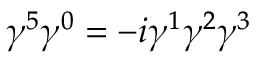<formula> <loc_0><loc_0><loc_500><loc_500>\gamma ^ { 5 } \gamma ^ { 0 } = - i \gamma ^ { 1 } \gamma ^ { 2 } \gamma ^ { 3 }</formula> 